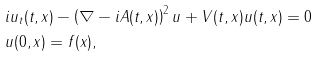<formula> <loc_0><loc_0><loc_500><loc_500>& i u _ { t } ( t , x ) - \left ( \nabla - i A ( t , x ) \right ) ^ { 2 } u + V ( t , x ) u ( t , x ) = 0 \\ & u ( 0 , x ) = f ( x ) ,</formula> 